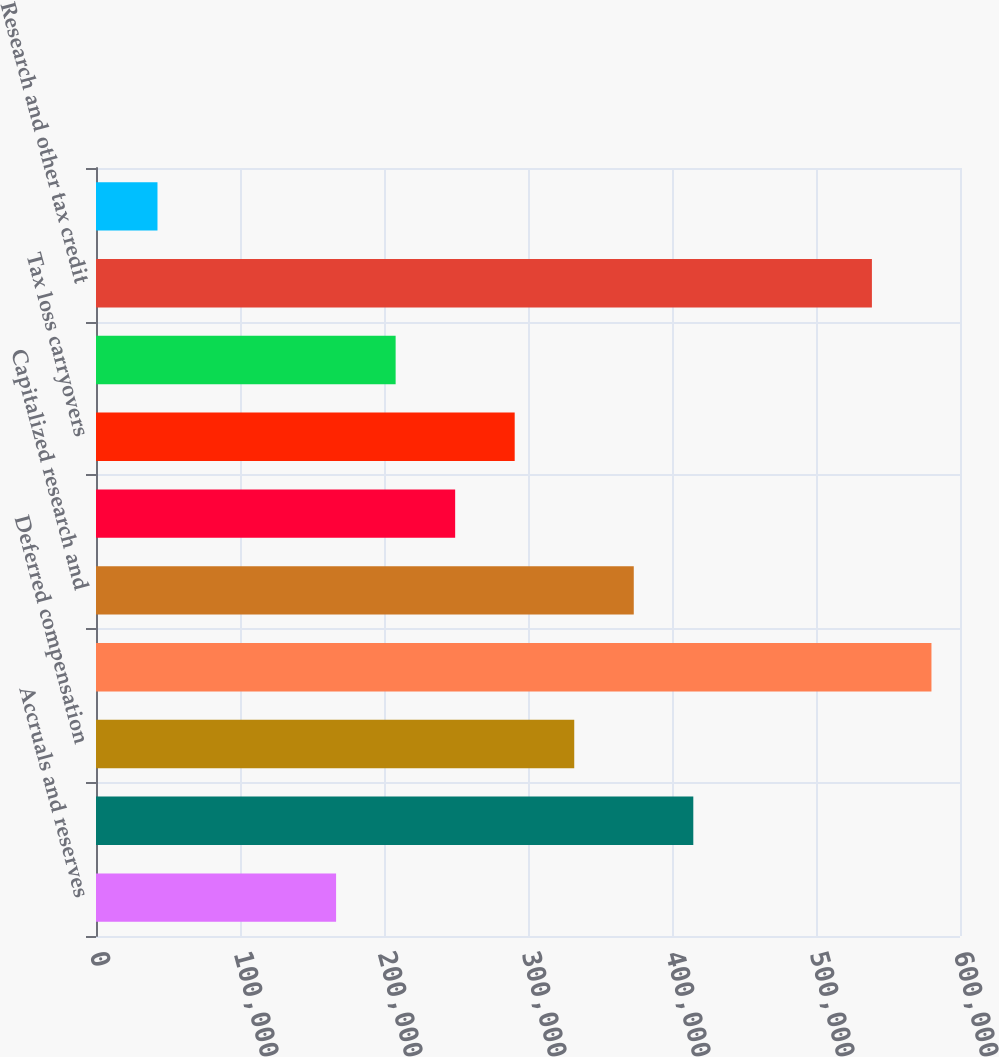<chart> <loc_0><loc_0><loc_500><loc_500><bar_chart><fcel>Accruals and reserves<fcel>Deferred revenue<fcel>Deferred compensation<fcel>Capitalized costs<fcel>Capitalized research and<fcel>Stock compensation<fcel>Tax loss carryovers<fcel>Foreign tax credit carryovers<fcel>Research and other tax credit<fcel>Capital loss carryovers<nl><fcel>166728<fcel>414797<fcel>332107<fcel>580176<fcel>373452<fcel>249418<fcel>290763<fcel>208073<fcel>538831<fcel>42693.8<nl></chart> 